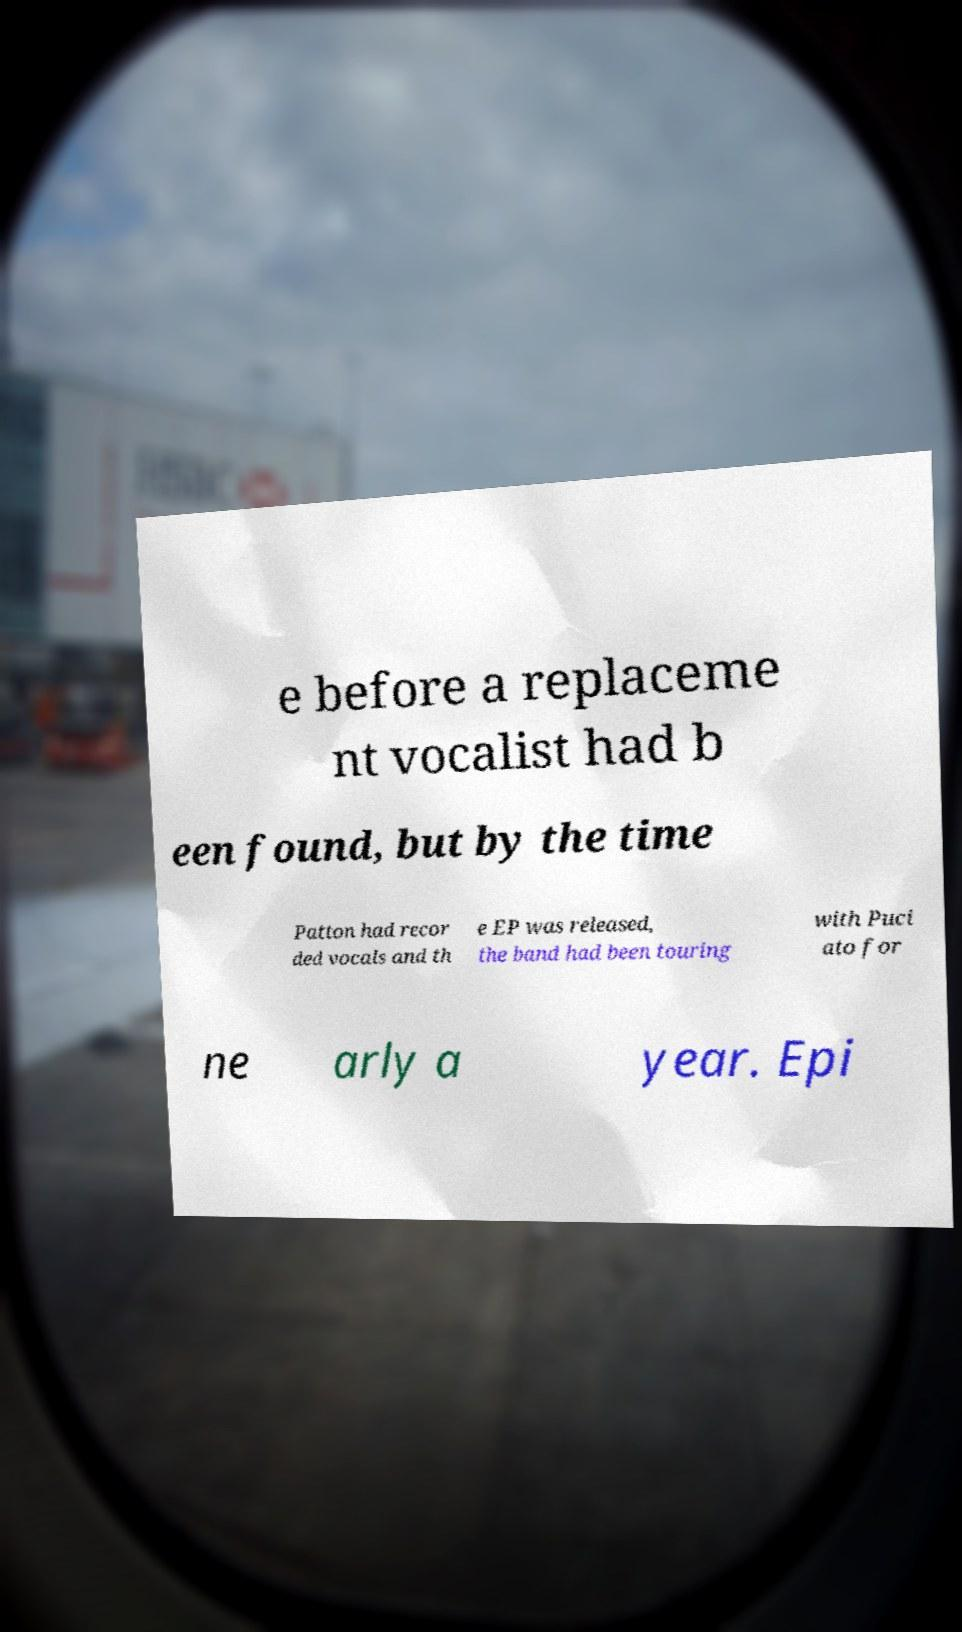What messages or text are displayed in this image? I need them in a readable, typed format. e before a replaceme nt vocalist had b een found, but by the time Patton had recor ded vocals and th e EP was released, the band had been touring with Puci ato for ne arly a year. Epi 